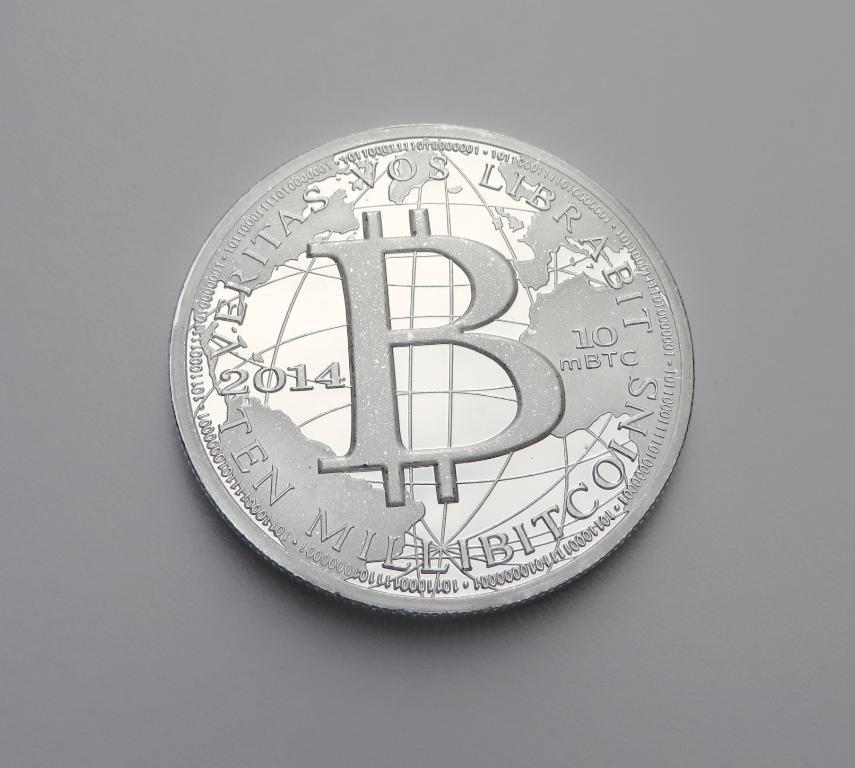Provide a one-sentence caption for the provided image. silver coin from 2014 that states verotas vos librabit. 